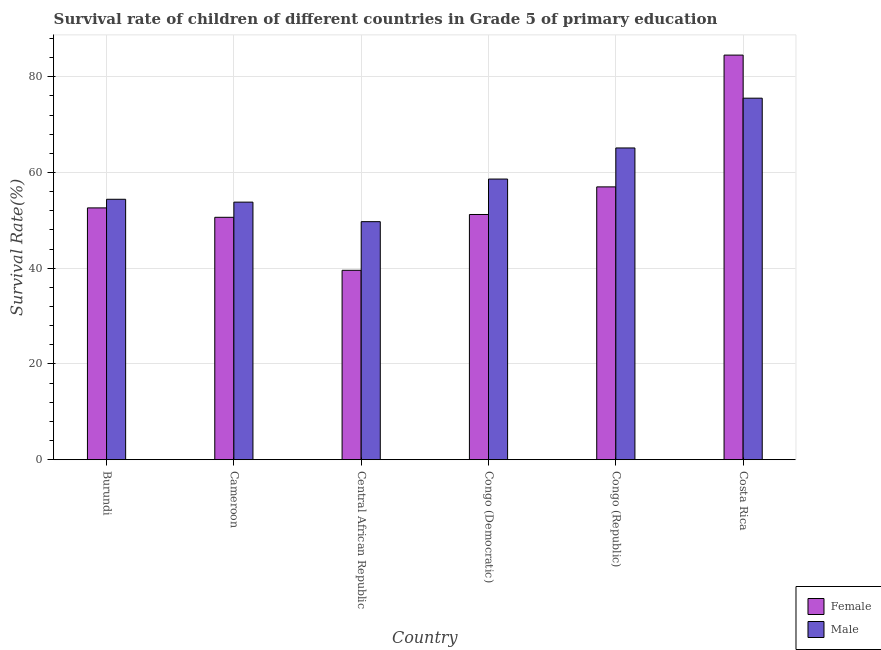How many groups of bars are there?
Your response must be concise. 6. Are the number of bars per tick equal to the number of legend labels?
Your answer should be very brief. Yes. What is the label of the 4th group of bars from the left?
Offer a very short reply. Congo (Democratic). In how many cases, is the number of bars for a given country not equal to the number of legend labels?
Offer a very short reply. 0. What is the survival rate of female students in primary education in Central African Republic?
Provide a short and direct response. 39.57. Across all countries, what is the maximum survival rate of female students in primary education?
Keep it short and to the point. 84.53. Across all countries, what is the minimum survival rate of female students in primary education?
Your response must be concise. 39.57. In which country was the survival rate of female students in primary education minimum?
Make the answer very short. Central African Republic. What is the total survival rate of female students in primary education in the graph?
Ensure brevity in your answer.  335.58. What is the difference between the survival rate of male students in primary education in Burundi and that in Congo (Republic)?
Give a very brief answer. -10.72. What is the difference between the survival rate of female students in primary education in Congo (Republic) and the survival rate of male students in primary education in Costa Rica?
Ensure brevity in your answer.  -18.53. What is the average survival rate of male students in primary education per country?
Ensure brevity in your answer.  59.54. What is the difference between the survival rate of female students in primary education and survival rate of male students in primary education in Burundi?
Provide a succinct answer. -1.8. In how many countries, is the survival rate of male students in primary education greater than 64 %?
Make the answer very short. 2. What is the ratio of the survival rate of female students in primary education in Cameroon to that in Central African Republic?
Your response must be concise. 1.28. Is the survival rate of female students in primary education in Congo (Democratic) less than that in Congo (Republic)?
Offer a very short reply. Yes. Is the difference between the survival rate of female students in primary education in Cameroon and Central African Republic greater than the difference between the survival rate of male students in primary education in Cameroon and Central African Republic?
Your response must be concise. Yes. What is the difference between the highest and the second highest survival rate of female students in primary education?
Give a very brief answer. 27.53. What is the difference between the highest and the lowest survival rate of male students in primary education?
Make the answer very short. 25.8. In how many countries, is the survival rate of male students in primary education greater than the average survival rate of male students in primary education taken over all countries?
Your answer should be very brief. 2. How many bars are there?
Offer a terse response. 12. Does the graph contain grids?
Ensure brevity in your answer.  Yes. Where does the legend appear in the graph?
Ensure brevity in your answer.  Bottom right. What is the title of the graph?
Give a very brief answer. Survival rate of children of different countries in Grade 5 of primary education. Does "Rural" appear as one of the legend labels in the graph?
Give a very brief answer. No. What is the label or title of the Y-axis?
Ensure brevity in your answer.  Survival Rate(%). What is the Survival Rate(%) in Female in Burundi?
Offer a very short reply. 52.61. What is the Survival Rate(%) in Male in Burundi?
Offer a very short reply. 54.41. What is the Survival Rate(%) in Female in Cameroon?
Your response must be concise. 50.64. What is the Survival Rate(%) of Male in Cameroon?
Provide a succinct answer. 53.81. What is the Survival Rate(%) in Female in Central African Republic?
Offer a very short reply. 39.57. What is the Survival Rate(%) in Male in Central African Republic?
Your response must be concise. 49.73. What is the Survival Rate(%) of Female in Congo (Democratic)?
Provide a short and direct response. 51.23. What is the Survival Rate(%) in Male in Congo (Democratic)?
Your response must be concise. 58.64. What is the Survival Rate(%) of Female in Congo (Republic)?
Keep it short and to the point. 57. What is the Survival Rate(%) in Male in Congo (Republic)?
Your response must be concise. 65.13. What is the Survival Rate(%) in Female in Costa Rica?
Keep it short and to the point. 84.53. What is the Survival Rate(%) in Male in Costa Rica?
Offer a terse response. 75.53. Across all countries, what is the maximum Survival Rate(%) of Female?
Make the answer very short. 84.53. Across all countries, what is the maximum Survival Rate(%) in Male?
Your response must be concise. 75.53. Across all countries, what is the minimum Survival Rate(%) in Female?
Provide a short and direct response. 39.57. Across all countries, what is the minimum Survival Rate(%) of Male?
Offer a very short reply. 49.73. What is the total Survival Rate(%) of Female in the graph?
Keep it short and to the point. 335.58. What is the total Survival Rate(%) in Male in the graph?
Your answer should be very brief. 357.26. What is the difference between the Survival Rate(%) in Female in Burundi and that in Cameroon?
Offer a very short reply. 1.97. What is the difference between the Survival Rate(%) of Male in Burundi and that in Cameroon?
Give a very brief answer. 0.6. What is the difference between the Survival Rate(%) of Female in Burundi and that in Central African Republic?
Your answer should be compact. 13.04. What is the difference between the Survival Rate(%) in Male in Burundi and that in Central African Republic?
Make the answer very short. 4.68. What is the difference between the Survival Rate(%) of Female in Burundi and that in Congo (Democratic)?
Provide a short and direct response. 1.38. What is the difference between the Survival Rate(%) in Male in Burundi and that in Congo (Democratic)?
Your answer should be very brief. -4.23. What is the difference between the Survival Rate(%) in Female in Burundi and that in Congo (Republic)?
Give a very brief answer. -4.39. What is the difference between the Survival Rate(%) of Male in Burundi and that in Congo (Republic)?
Your answer should be compact. -10.72. What is the difference between the Survival Rate(%) of Female in Burundi and that in Costa Rica?
Make the answer very short. -31.92. What is the difference between the Survival Rate(%) of Male in Burundi and that in Costa Rica?
Provide a short and direct response. -21.12. What is the difference between the Survival Rate(%) of Female in Cameroon and that in Central African Republic?
Your response must be concise. 11.07. What is the difference between the Survival Rate(%) of Male in Cameroon and that in Central African Republic?
Make the answer very short. 4.08. What is the difference between the Survival Rate(%) in Female in Cameroon and that in Congo (Democratic)?
Provide a short and direct response. -0.59. What is the difference between the Survival Rate(%) of Male in Cameroon and that in Congo (Democratic)?
Ensure brevity in your answer.  -4.82. What is the difference between the Survival Rate(%) of Female in Cameroon and that in Congo (Republic)?
Offer a very short reply. -6.36. What is the difference between the Survival Rate(%) of Male in Cameroon and that in Congo (Republic)?
Your answer should be compact. -11.32. What is the difference between the Survival Rate(%) of Female in Cameroon and that in Costa Rica?
Keep it short and to the point. -33.89. What is the difference between the Survival Rate(%) of Male in Cameroon and that in Costa Rica?
Ensure brevity in your answer.  -21.72. What is the difference between the Survival Rate(%) in Female in Central African Republic and that in Congo (Democratic)?
Ensure brevity in your answer.  -11.66. What is the difference between the Survival Rate(%) in Male in Central African Republic and that in Congo (Democratic)?
Provide a short and direct response. -8.9. What is the difference between the Survival Rate(%) in Female in Central African Republic and that in Congo (Republic)?
Keep it short and to the point. -17.43. What is the difference between the Survival Rate(%) of Male in Central African Republic and that in Congo (Republic)?
Offer a very short reply. -15.4. What is the difference between the Survival Rate(%) of Female in Central African Republic and that in Costa Rica?
Your answer should be very brief. -44.96. What is the difference between the Survival Rate(%) of Male in Central African Republic and that in Costa Rica?
Provide a short and direct response. -25.8. What is the difference between the Survival Rate(%) of Female in Congo (Democratic) and that in Congo (Republic)?
Give a very brief answer. -5.77. What is the difference between the Survival Rate(%) of Male in Congo (Democratic) and that in Congo (Republic)?
Offer a very short reply. -6.5. What is the difference between the Survival Rate(%) of Female in Congo (Democratic) and that in Costa Rica?
Your response must be concise. -33.3. What is the difference between the Survival Rate(%) in Male in Congo (Democratic) and that in Costa Rica?
Provide a short and direct response. -16.9. What is the difference between the Survival Rate(%) in Female in Congo (Republic) and that in Costa Rica?
Your response must be concise. -27.53. What is the difference between the Survival Rate(%) of Male in Congo (Republic) and that in Costa Rica?
Your response must be concise. -10.4. What is the difference between the Survival Rate(%) in Female in Burundi and the Survival Rate(%) in Male in Cameroon?
Ensure brevity in your answer.  -1.21. What is the difference between the Survival Rate(%) of Female in Burundi and the Survival Rate(%) of Male in Central African Republic?
Offer a terse response. 2.87. What is the difference between the Survival Rate(%) of Female in Burundi and the Survival Rate(%) of Male in Congo (Democratic)?
Ensure brevity in your answer.  -6.03. What is the difference between the Survival Rate(%) in Female in Burundi and the Survival Rate(%) in Male in Congo (Republic)?
Make the answer very short. -12.52. What is the difference between the Survival Rate(%) in Female in Burundi and the Survival Rate(%) in Male in Costa Rica?
Your answer should be compact. -22.92. What is the difference between the Survival Rate(%) in Female in Cameroon and the Survival Rate(%) in Male in Central African Republic?
Provide a succinct answer. 0.91. What is the difference between the Survival Rate(%) in Female in Cameroon and the Survival Rate(%) in Male in Congo (Democratic)?
Give a very brief answer. -7.99. What is the difference between the Survival Rate(%) of Female in Cameroon and the Survival Rate(%) of Male in Congo (Republic)?
Provide a short and direct response. -14.49. What is the difference between the Survival Rate(%) of Female in Cameroon and the Survival Rate(%) of Male in Costa Rica?
Offer a very short reply. -24.89. What is the difference between the Survival Rate(%) in Female in Central African Republic and the Survival Rate(%) in Male in Congo (Democratic)?
Your answer should be very brief. -19.07. What is the difference between the Survival Rate(%) in Female in Central African Republic and the Survival Rate(%) in Male in Congo (Republic)?
Make the answer very short. -25.56. What is the difference between the Survival Rate(%) of Female in Central African Republic and the Survival Rate(%) of Male in Costa Rica?
Your answer should be very brief. -35.96. What is the difference between the Survival Rate(%) in Female in Congo (Democratic) and the Survival Rate(%) in Male in Congo (Republic)?
Your response must be concise. -13.9. What is the difference between the Survival Rate(%) in Female in Congo (Democratic) and the Survival Rate(%) in Male in Costa Rica?
Make the answer very short. -24.3. What is the difference between the Survival Rate(%) of Female in Congo (Republic) and the Survival Rate(%) of Male in Costa Rica?
Your answer should be compact. -18.53. What is the average Survival Rate(%) in Female per country?
Ensure brevity in your answer.  55.93. What is the average Survival Rate(%) in Male per country?
Your response must be concise. 59.54. What is the difference between the Survival Rate(%) in Female and Survival Rate(%) in Male in Burundi?
Make the answer very short. -1.8. What is the difference between the Survival Rate(%) of Female and Survival Rate(%) of Male in Cameroon?
Provide a succinct answer. -3.17. What is the difference between the Survival Rate(%) in Female and Survival Rate(%) in Male in Central African Republic?
Provide a succinct answer. -10.16. What is the difference between the Survival Rate(%) in Female and Survival Rate(%) in Male in Congo (Democratic)?
Provide a short and direct response. -7.41. What is the difference between the Survival Rate(%) of Female and Survival Rate(%) of Male in Congo (Republic)?
Provide a succinct answer. -8.13. What is the difference between the Survival Rate(%) in Female and Survival Rate(%) in Male in Costa Rica?
Provide a succinct answer. 9. What is the ratio of the Survival Rate(%) in Female in Burundi to that in Cameroon?
Make the answer very short. 1.04. What is the ratio of the Survival Rate(%) of Male in Burundi to that in Cameroon?
Offer a very short reply. 1.01. What is the ratio of the Survival Rate(%) of Female in Burundi to that in Central African Republic?
Offer a very short reply. 1.33. What is the ratio of the Survival Rate(%) of Male in Burundi to that in Central African Republic?
Make the answer very short. 1.09. What is the ratio of the Survival Rate(%) of Female in Burundi to that in Congo (Democratic)?
Offer a terse response. 1.03. What is the ratio of the Survival Rate(%) of Male in Burundi to that in Congo (Democratic)?
Give a very brief answer. 0.93. What is the ratio of the Survival Rate(%) of Female in Burundi to that in Congo (Republic)?
Your response must be concise. 0.92. What is the ratio of the Survival Rate(%) of Male in Burundi to that in Congo (Republic)?
Your response must be concise. 0.84. What is the ratio of the Survival Rate(%) of Female in Burundi to that in Costa Rica?
Your answer should be compact. 0.62. What is the ratio of the Survival Rate(%) in Male in Burundi to that in Costa Rica?
Ensure brevity in your answer.  0.72. What is the ratio of the Survival Rate(%) in Female in Cameroon to that in Central African Republic?
Make the answer very short. 1.28. What is the ratio of the Survival Rate(%) in Male in Cameroon to that in Central African Republic?
Keep it short and to the point. 1.08. What is the ratio of the Survival Rate(%) in Male in Cameroon to that in Congo (Democratic)?
Keep it short and to the point. 0.92. What is the ratio of the Survival Rate(%) in Female in Cameroon to that in Congo (Republic)?
Offer a very short reply. 0.89. What is the ratio of the Survival Rate(%) in Male in Cameroon to that in Congo (Republic)?
Offer a very short reply. 0.83. What is the ratio of the Survival Rate(%) of Female in Cameroon to that in Costa Rica?
Ensure brevity in your answer.  0.6. What is the ratio of the Survival Rate(%) in Male in Cameroon to that in Costa Rica?
Offer a terse response. 0.71. What is the ratio of the Survival Rate(%) of Female in Central African Republic to that in Congo (Democratic)?
Ensure brevity in your answer.  0.77. What is the ratio of the Survival Rate(%) of Male in Central African Republic to that in Congo (Democratic)?
Your answer should be very brief. 0.85. What is the ratio of the Survival Rate(%) in Female in Central African Republic to that in Congo (Republic)?
Ensure brevity in your answer.  0.69. What is the ratio of the Survival Rate(%) of Male in Central African Republic to that in Congo (Republic)?
Keep it short and to the point. 0.76. What is the ratio of the Survival Rate(%) of Female in Central African Republic to that in Costa Rica?
Give a very brief answer. 0.47. What is the ratio of the Survival Rate(%) in Male in Central African Republic to that in Costa Rica?
Your answer should be very brief. 0.66. What is the ratio of the Survival Rate(%) in Female in Congo (Democratic) to that in Congo (Republic)?
Give a very brief answer. 0.9. What is the ratio of the Survival Rate(%) of Male in Congo (Democratic) to that in Congo (Republic)?
Keep it short and to the point. 0.9. What is the ratio of the Survival Rate(%) in Female in Congo (Democratic) to that in Costa Rica?
Keep it short and to the point. 0.61. What is the ratio of the Survival Rate(%) in Male in Congo (Democratic) to that in Costa Rica?
Offer a very short reply. 0.78. What is the ratio of the Survival Rate(%) of Female in Congo (Republic) to that in Costa Rica?
Keep it short and to the point. 0.67. What is the ratio of the Survival Rate(%) in Male in Congo (Republic) to that in Costa Rica?
Your response must be concise. 0.86. What is the difference between the highest and the second highest Survival Rate(%) in Female?
Keep it short and to the point. 27.53. What is the difference between the highest and the second highest Survival Rate(%) of Male?
Make the answer very short. 10.4. What is the difference between the highest and the lowest Survival Rate(%) of Female?
Your answer should be compact. 44.96. What is the difference between the highest and the lowest Survival Rate(%) in Male?
Your response must be concise. 25.8. 